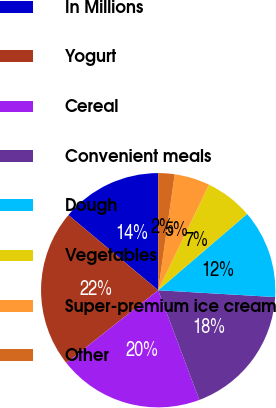Convert chart to OTSL. <chart><loc_0><loc_0><loc_500><loc_500><pie_chart><fcel>In Millions<fcel>Yogurt<fcel>Cereal<fcel>Convenient meals<fcel>Dough<fcel>Vegetables<fcel>Super-premium ice cream<fcel>Other<nl><fcel>13.9%<fcel>21.75%<fcel>20.06%<fcel>18.37%<fcel>12.21%<fcel>6.58%<fcel>4.89%<fcel>2.26%<nl></chart> 